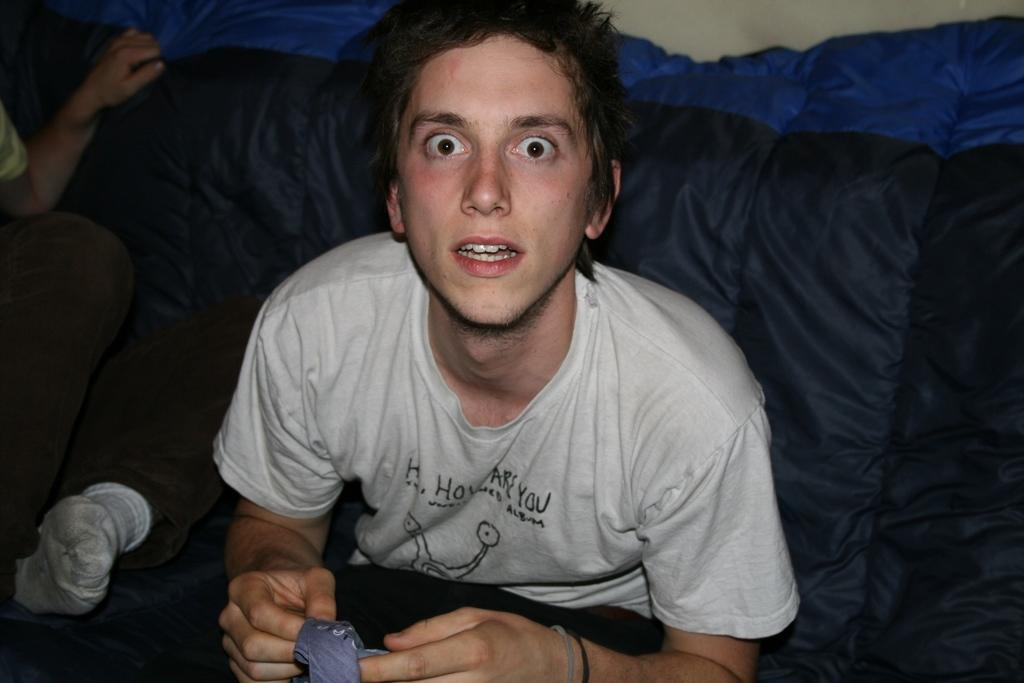Who or what is the main subject of the image? There is a person in the image. What is the person wearing? The person is wearing an ash-colored dress. Can you describe the background of the image? There is a blue and black color object in the background of the image. What type of business is the person conducting in the image? There is no indication of a business or any business-related activity in the image. 